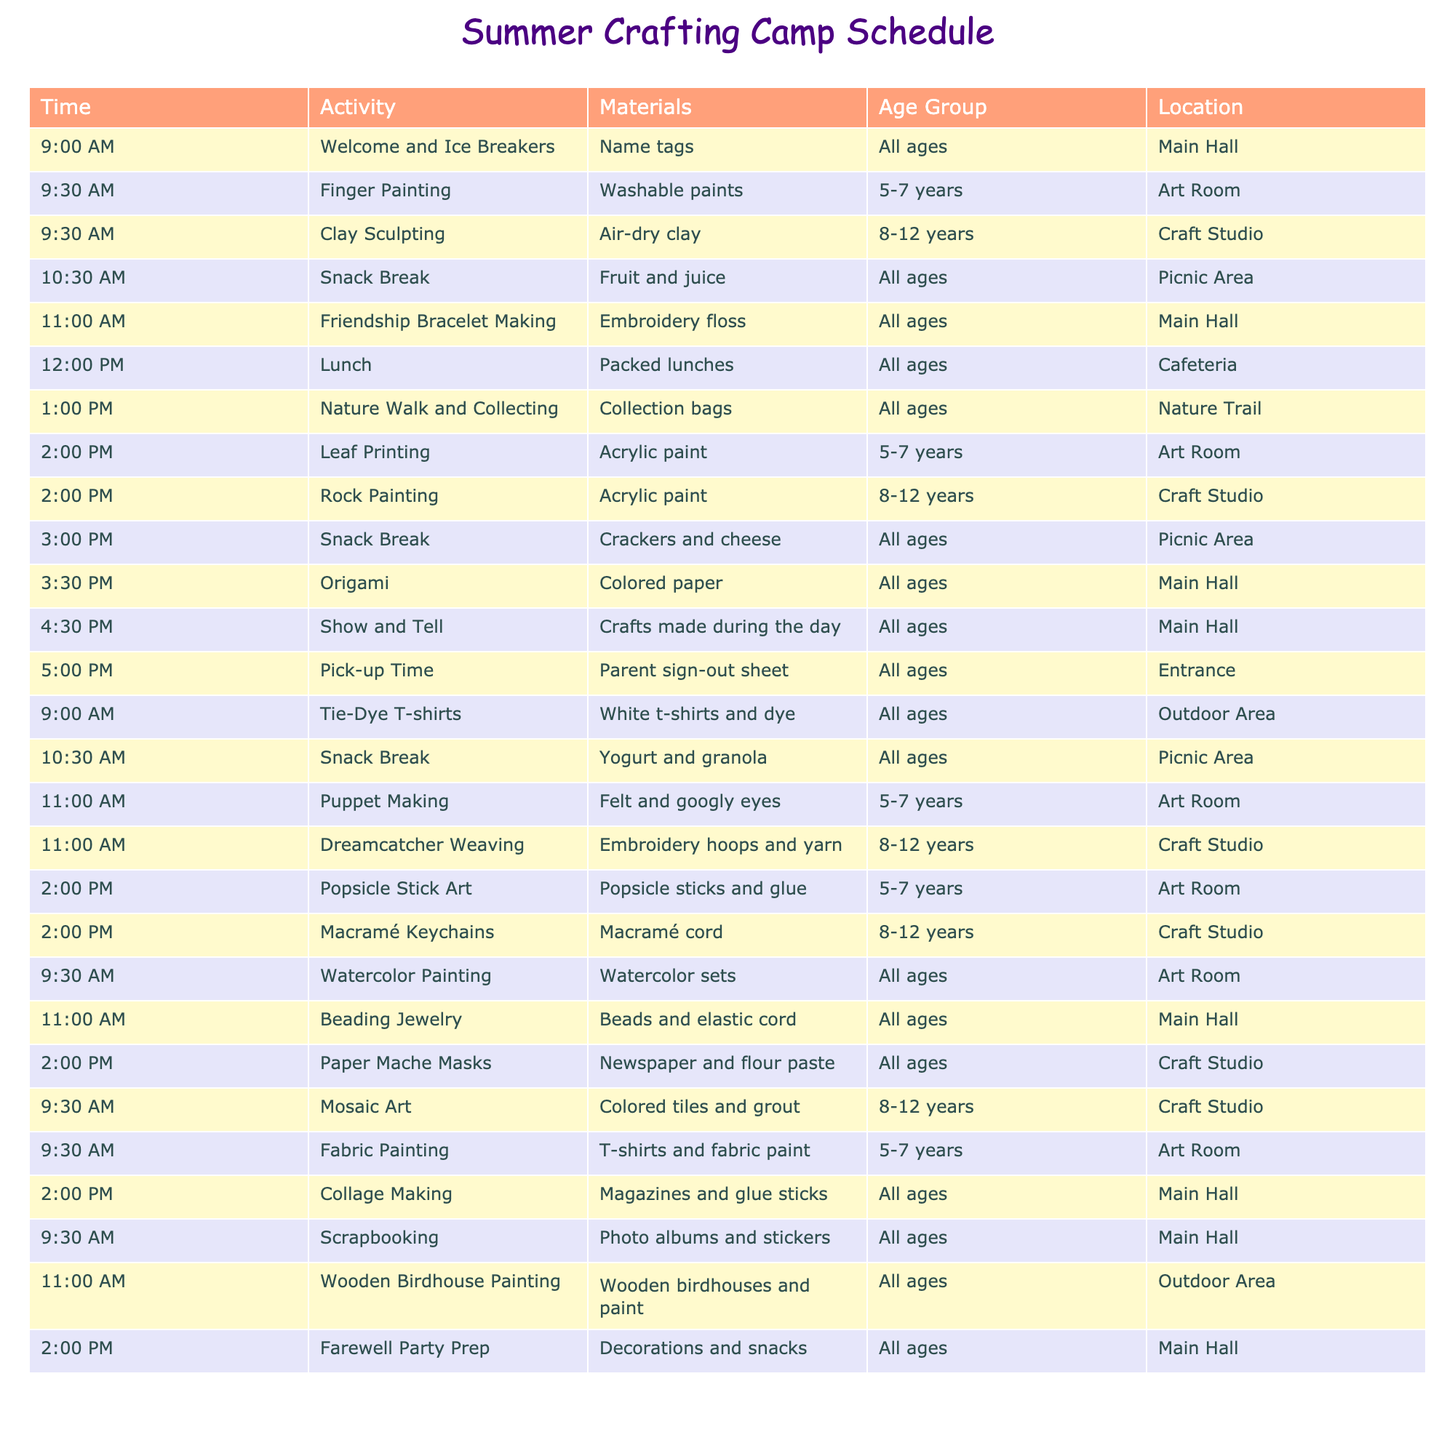What activity starts at 9:30 AM? The table shows that two activities start at 9:30 AM: Finger Painting (in the Art Room) and Clay Sculpting (in the Craft Studio).
Answer: Finger Painting and Clay Sculpting How many snack breaks are there during the camp? By examining the table, I see that there are three snack breaks at different times: 10:30 AM, 3:00 PM, and 10:30 AM on the second day. That's a total of three snacks breaks.
Answer: 3 What materials do we need for Origami? Looking at the table, it specifies that Origami requires colored paper as the material, which is mentioned in the corresponding row.
Answer: Colored paper Is there an activity for 8-12 year-olds that involves painting? The table lists two activities for 8-12 year-olds that involve painting: Clay Sculpting (not painting) and Rock Painting. Since Rock Painting is the only relevant activity, this fact can be confirmed as true.
Answer: Yes How many activities start at 2:00 PM? There are four activities listed that begin at 2:00 PM: Leaf Printing, Rock Painting, Popsicle Stick Art, and Macramé Keychains. So, we can count them: 4 activities start at 2:00 PM.
Answer: 4 Which location has the most activities scheduled? The locations are compared: the Main Hall has 5 activities (Welcome and Ice Breakers, Friendship Bracelet Making, Beading Jewelry, Collage Making, Show and Tell), while others have fewer. Therefore, the Main Hall has the most activities.
Answer: Main Hall Is there a Farewell Party Prep activity? The table shows a Farewell Party Prep activity scheduled at 2:00 PM, confirming that it exists in the camp schedule.
Answer: Yes What is the age group for Friendship Bracelet Making? The table indicates that Friendship Bracelet Making is suitable for all ages, specifying that it does not restrict participation by age in this activity.
Answer: All ages How many activities are scheduled between 1:00 PM and 3:00 PM? From the table, I see two activities scheduled during that time: Nature Walk and Collecting at 1:00 PM and one more at 2:00 PM (there are three such activities total including an origami activity afterwards). Thus, the count is three activities.
Answer: 3 What time does the camp end each day? By checking the table, we find that the last activity each day is at 5:00 PM, which is the Pick-up Time.
Answer: 5:00 PM 